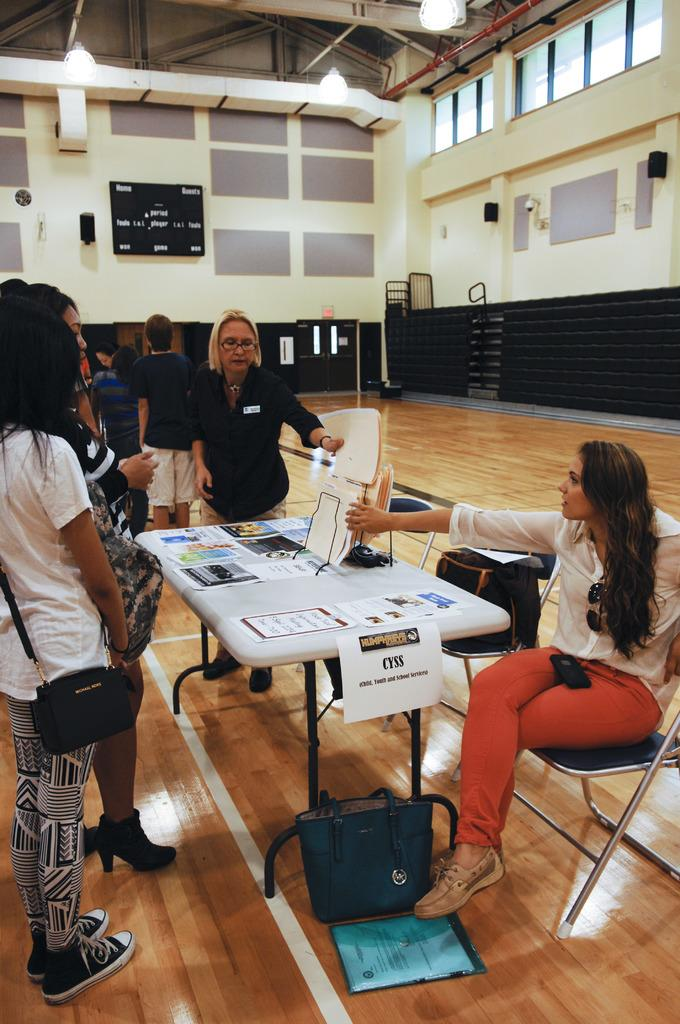What type of structure is visible in the image? There is a stadium in the image. What piece of furniture is present in the image? There is a chair in the image. Who is sitting on the chair? A woman is sitting on the chair. What other piece of furniture is furniture is visible in the image? There is a table in the image. What are the women near the table doing? There are women standing near the table. What time of day is it in the image, considering the presence of a friend? There is no mention of a friend in the image, and the time of day cannot be determined from the image alone. 